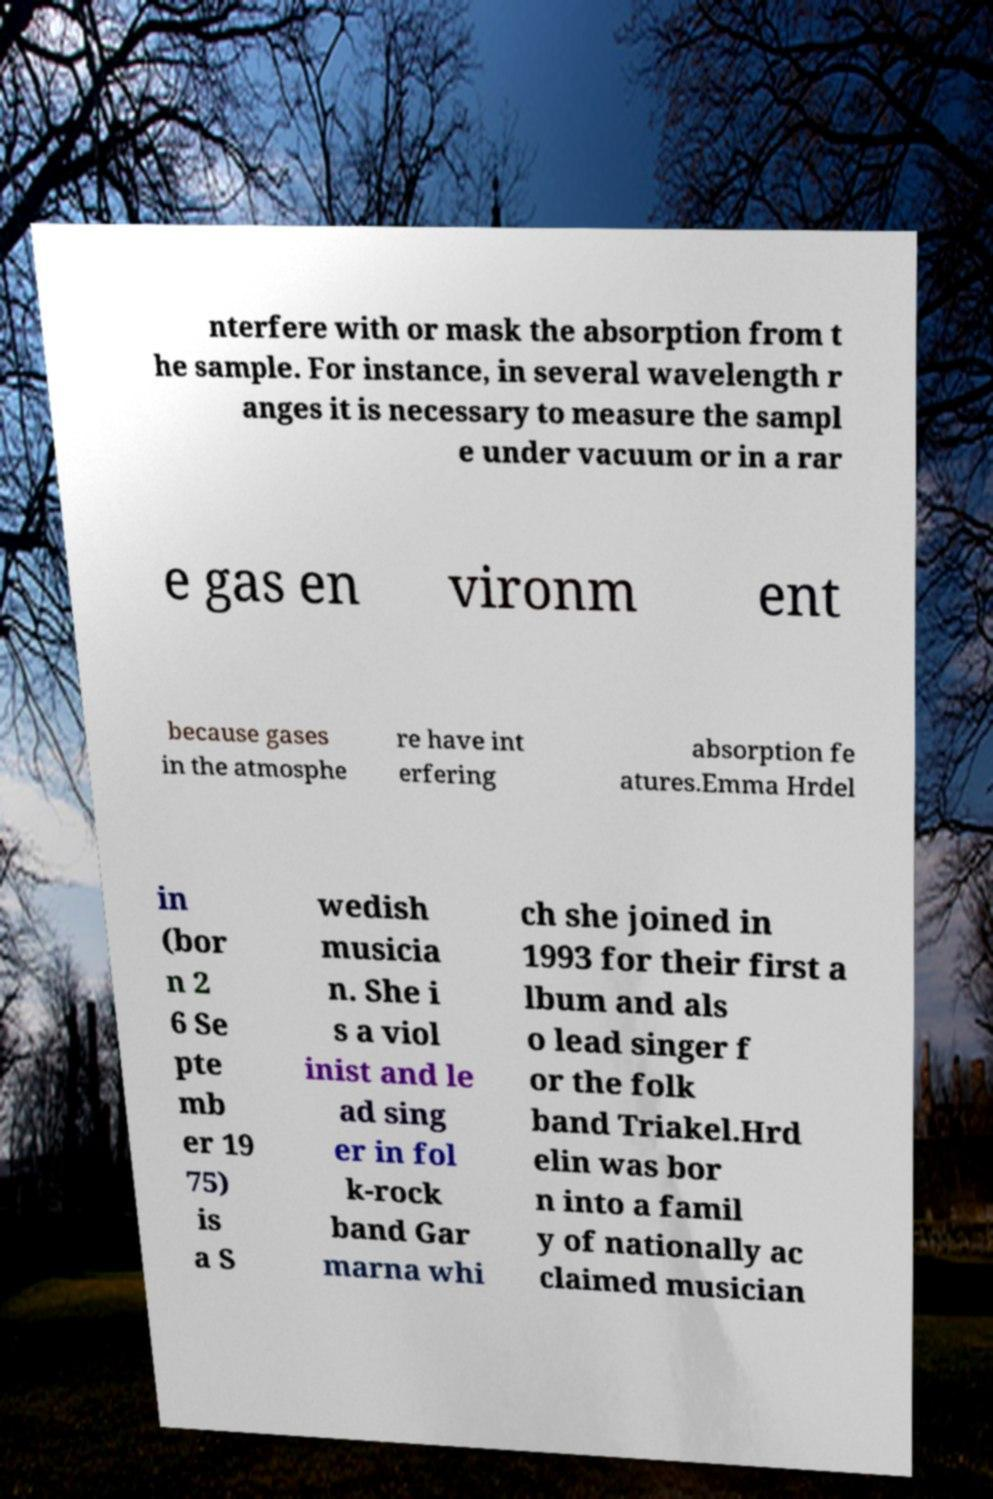Please read and relay the text visible in this image. What does it say? nterfere with or mask the absorption from t he sample. For instance, in several wavelength r anges it is necessary to measure the sampl e under vacuum or in a rar e gas en vironm ent because gases in the atmosphe re have int erfering absorption fe atures.Emma Hrdel in (bor n 2 6 Se pte mb er 19 75) is a S wedish musicia n. She i s a viol inist and le ad sing er in fol k-rock band Gar marna whi ch she joined in 1993 for their first a lbum and als o lead singer f or the folk band Triakel.Hrd elin was bor n into a famil y of nationally ac claimed musician 